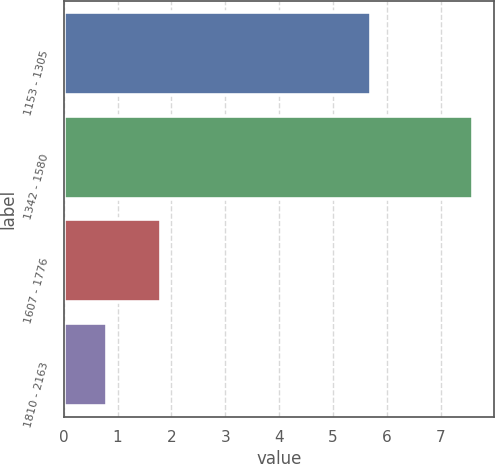Convert chart to OTSL. <chart><loc_0><loc_0><loc_500><loc_500><bar_chart><fcel>1153 - 1305<fcel>1342 - 1580<fcel>1607 - 1776<fcel>1810 - 2163<nl><fcel>5.7<fcel>7.6<fcel>1.8<fcel>0.8<nl></chart> 